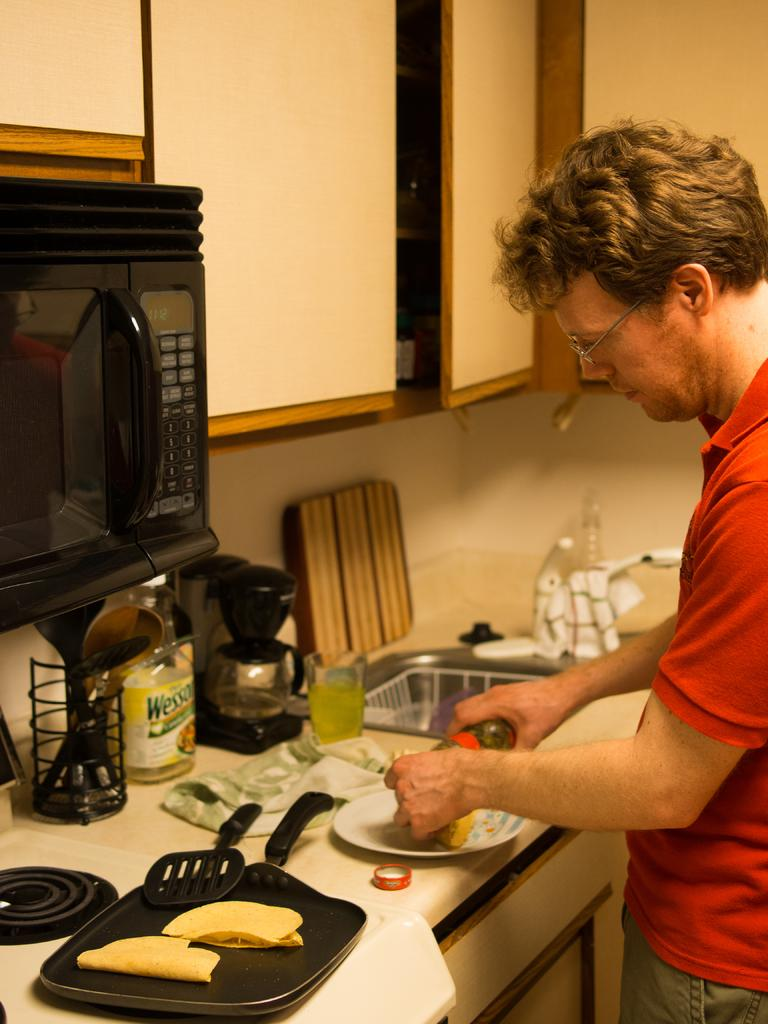<image>
Render a clear and concise summary of the photo. A man prepares food in his kitchen and there is a bottle of Wesson oil on the counter. 